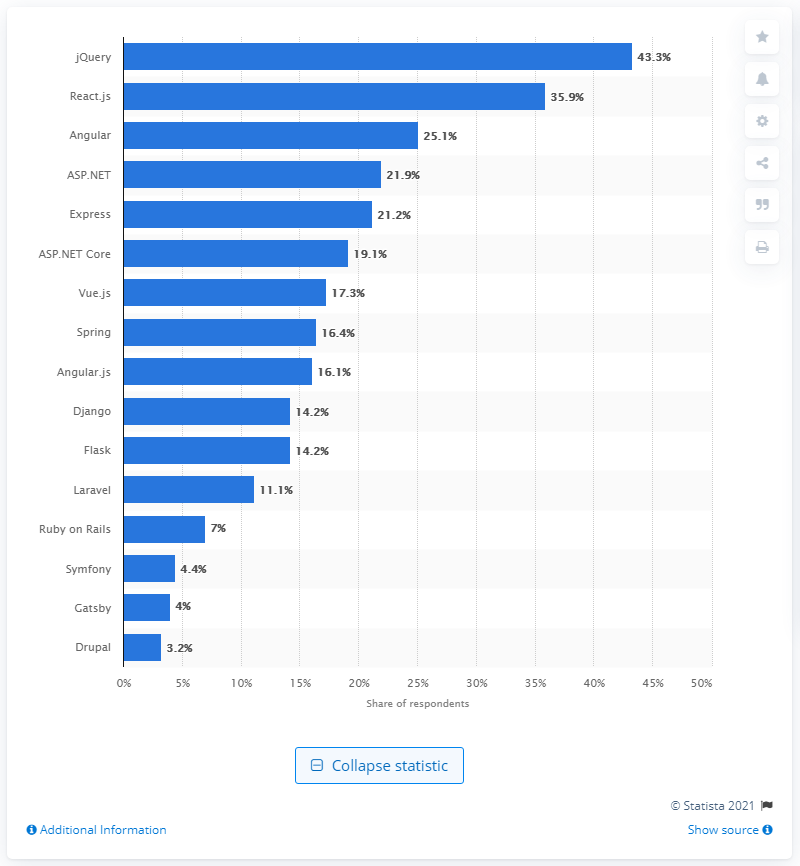Is Vue.js more popular than Angular according to this survey? According to this survey, Vue.js is less popular than Angular. Angular has a 25.1% share of respondents whereas Vue.js has a 17.3% share. 